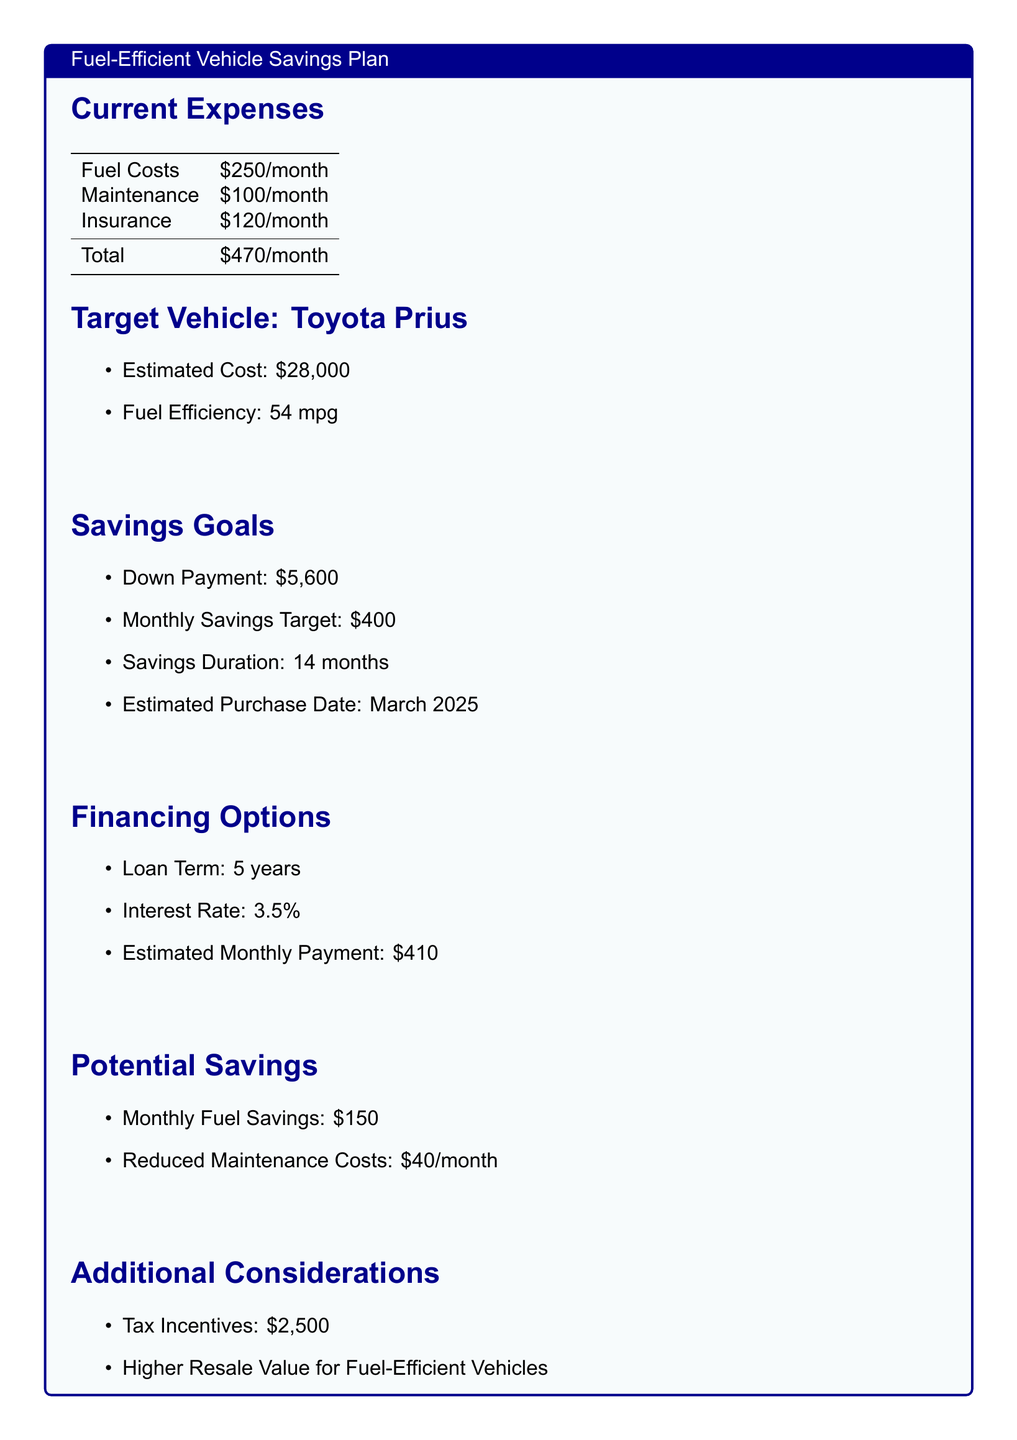what is the estimated cost of the target vehicle? The estimated cost of the Toyota Prius is provided in the document.
Answer: $28,000 what is the total monthly expense? The total monthly expense is calculated from the sum of fuel costs, maintenance, and insurance.
Answer: $470/month what is the monthly savings target? The document specifies a monthly savings target required to reach the down payment for the vehicle.
Answer: $400 how long is the savings duration? The savings duration indicates how long the commuter plans to save for the down payment.
Answer: 14 months what is the estimated monthly payment for financing? The estimated monthly payment for the loan is mentioned in the financing options section.
Answer: $410 what is the fuel efficiency of the target vehicle? The fuel efficiency of the Toyota Prius as listed in the document provides important information for savings calculations.
Answer: 54 mpg what tax incentive is mentioned? The document includes information about a potential tax incentive that can aid in the savings plan.
Answer: $2,500 what are the monthly fuel savings expected? The expected monthly fuel savings from purchasing the fuel-efficient vehicle are indicated in the potential savings section.
Answer: $150 what is the interest rate for the loan? The interest rate for the vehicle loan is specified under financing options in the document.
Answer: 3.5% 